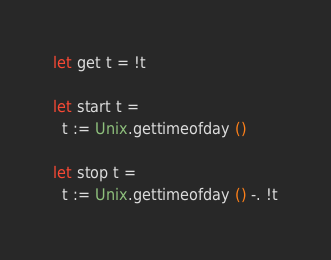<code> <loc_0><loc_0><loc_500><loc_500><_OCaml_>
let get t = !t

let start t =
  t := Unix.gettimeofday ()

let stop t =
  t := Unix.gettimeofday () -. !t
</code> 